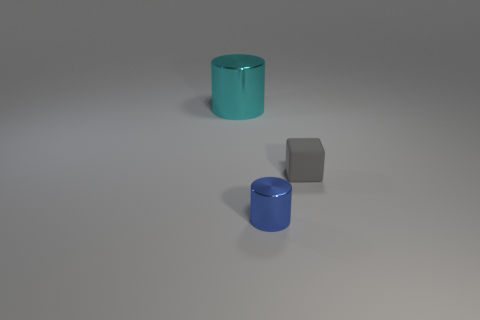Add 3 big purple metallic spheres. How many objects exist? 6 Subtract all blocks. How many objects are left? 2 Add 3 objects. How many objects exist? 6 Subtract 0 red balls. How many objects are left? 3 Subtract all small blue things. Subtract all metallic things. How many objects are left? 0 Add 3 small gray matte objects. How many small gray matte objects are left? 4 